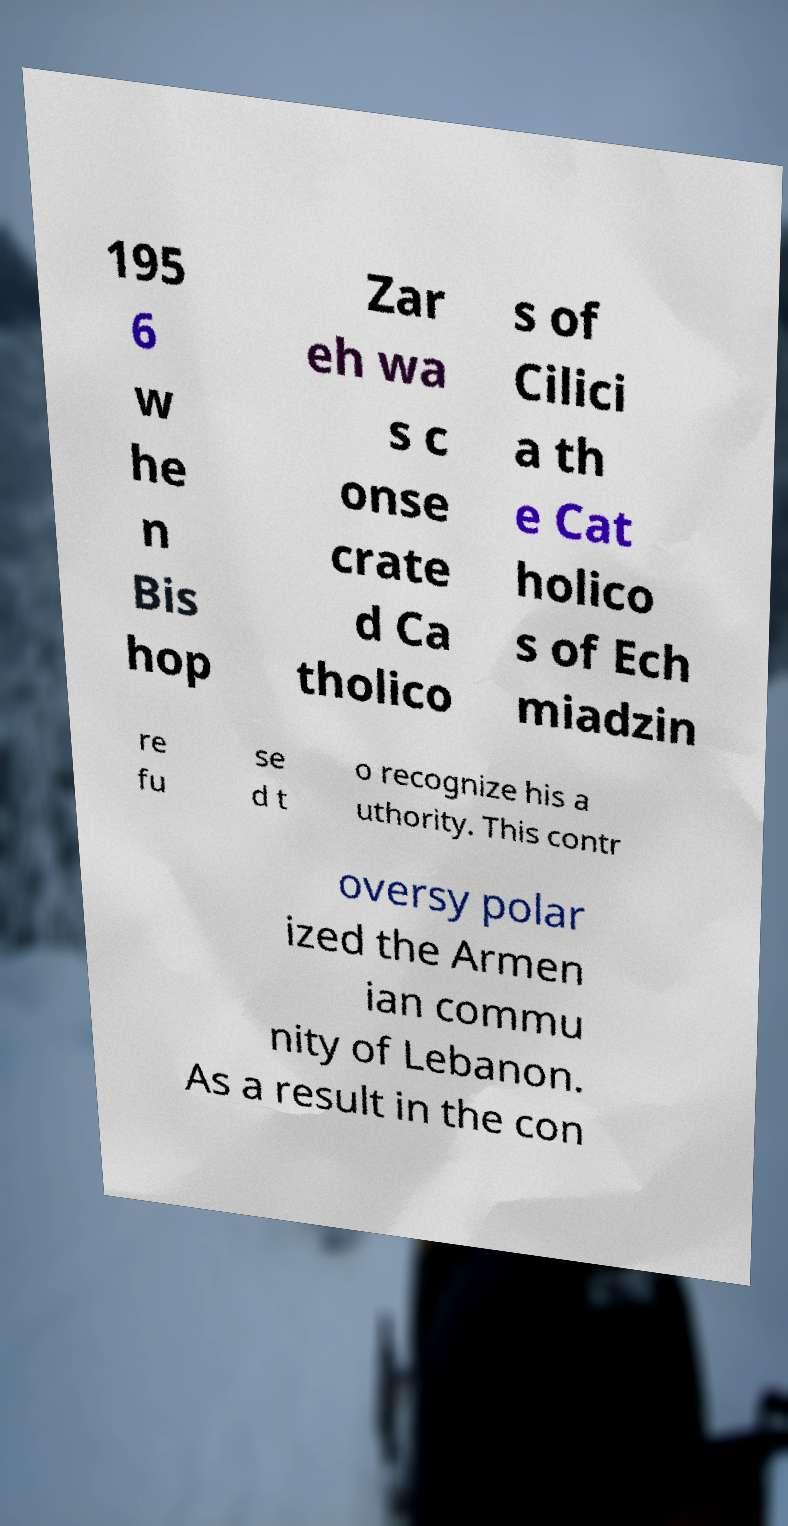Could you assist in decoding the text presented in this image and type it out clearly? 195 6 w he n Bis hop Zar eh wa s c onse crate d Ca tholico s of Cilici a th e Cat holico s of Ech miadzin re fu se d t o recognize his a uthority. This contr oversy polar ized the Armen ian commu nity of Lebanon. As a result in the con 